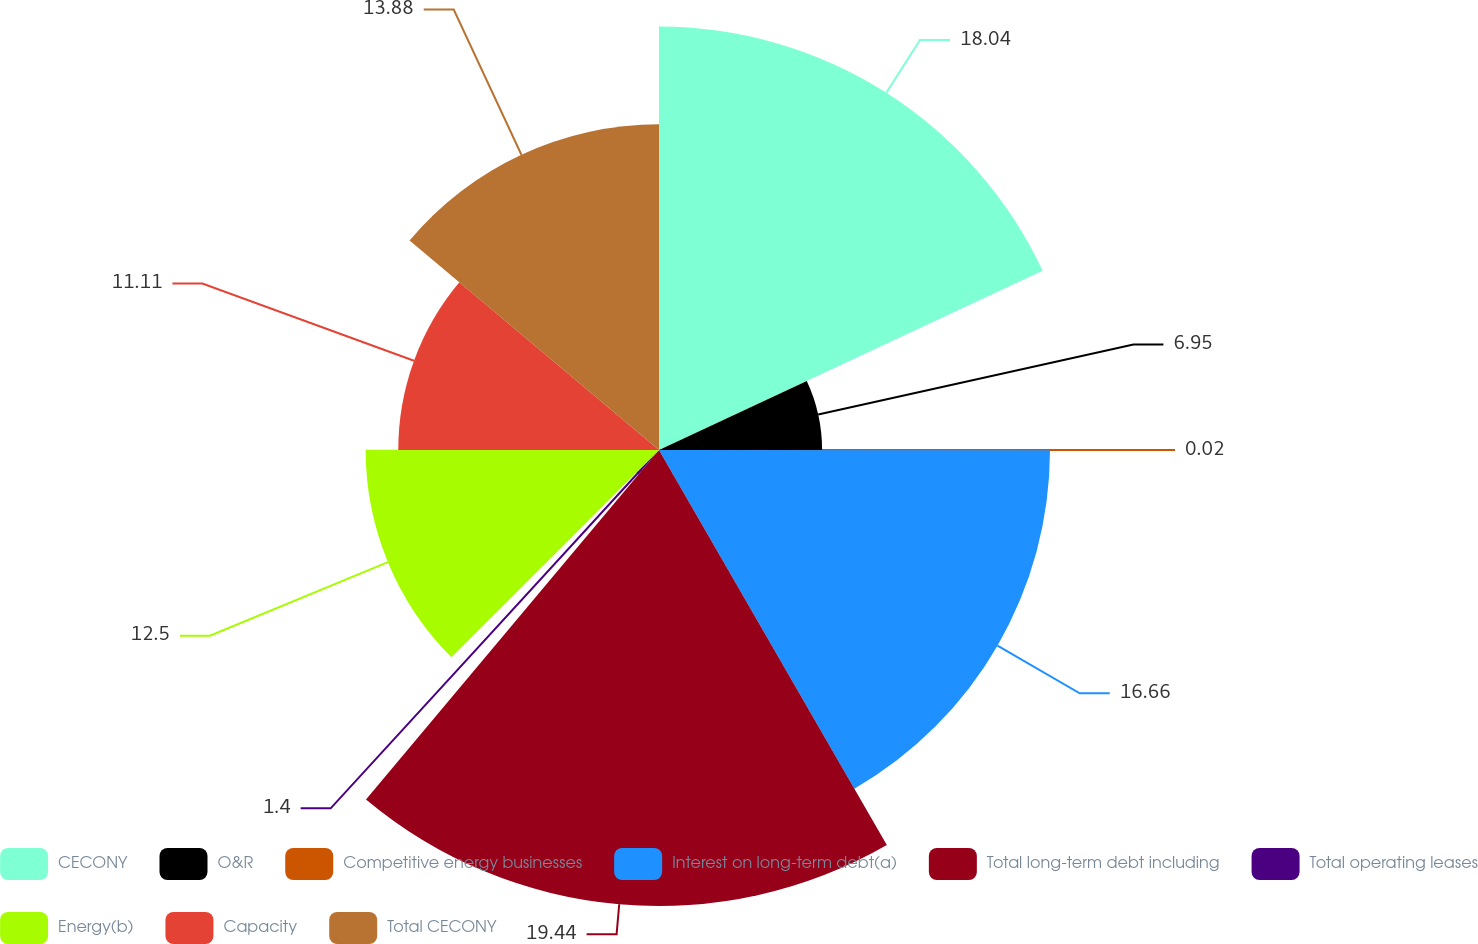<chart> <loc_0><loc_0><loc_500><loc_500><pie_chart><fcel>CECONY<fcel>O&R<fcel>Competitive energy businesses<fcel>Interest on long-term debt(a)<fcel>Total long-term debt including<fcel>Total operating leases<fcel>Energy(b)<fcel>Capacity<fcel>Total CECONY<nl><fcel>18.04%<fcel>6.95%<fcel>0.02%<fcel>16.66%<fcel>19.43%<fcel>1.4%<fcel>12.5%<fcel>11.11%<fcel>13.88%<nl></chart> 